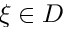Convert formula to latex. <formula><loc_0><loc_0><loc_500><loc_500>\xi \in D</formula> 